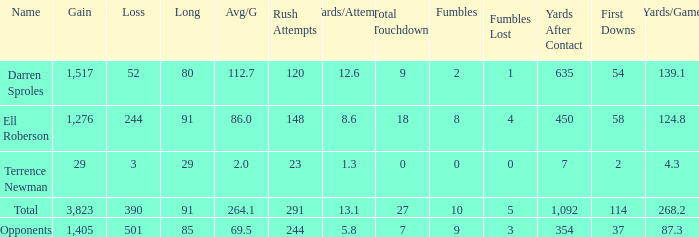What is the combined amount of all median yards gained when the yards gained is under 1,276 and lost more than 3 yards? None. 